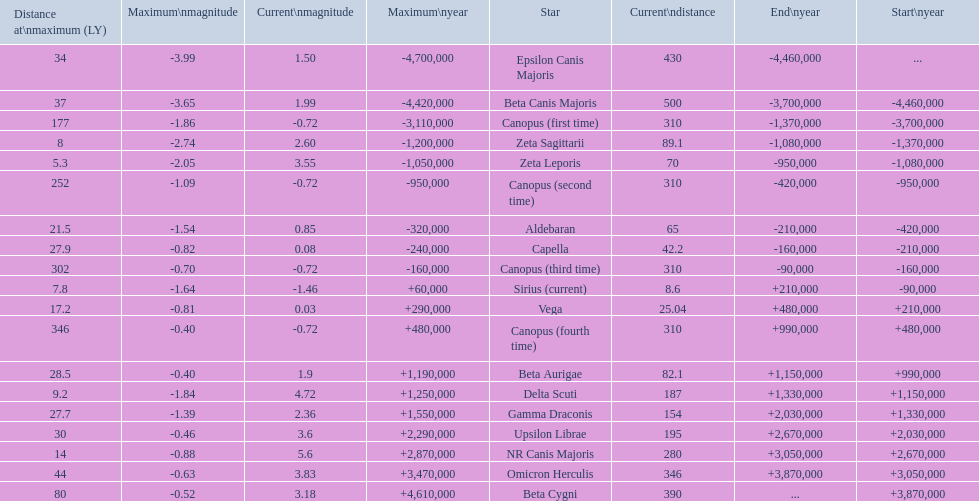Give me the full table as a dictionary. {'header': ['Distance at\\nmaximum (LY)', 'Maximum\\nmagnitude', 'Current\\nmagnitude', 'Maximum\\nyear', 'Star', 'Current\\ndistance', 'End\\nyear', 'Start\\nyear'], 'rows': [['34', '-3.99', '1.50', '-4,700,000', 'Epsilon Canis Majoris', '430', '-4,460,000', '...'], ['37', '-3.65', '1.99', '-4,420,000', 'Beta Canis Majoris', '500', '-3,700,000', '-4,460,000'], ['177', '-1.86', '-0.72', '-3,110,000', 'Canopus (first time)', '310', '-1,370,000', '-3,700,000'], ['8', '-2.74', '2.60', '-1,200,000', 'Zeta Sagittarii', '89.1', '-1,080,000', '-1,370,000'], ['5.3', '-2.05', '3.55', '-1,050,000', 'Zeta Leporis', '70', '-950,000', '-1,080,000'], ['252', '-1.09', '-0.72', '-950,000', 'Canopus (second time)', '310', '-420,000', '-950,000'], ['21.5', '-1.54', '0.85', '-320,000', 'Aldebaran', '65', '-210,000', '-420,000'], ['27.9', '-0.82', '0.08', '-240,000', 'Capella', '42.2', '-160,000', '-210,000'], ['302', '-0.70', '-0.72', '-160,000', 'Canopus (third time)', '310', '-90,000', '-160,000'], ['7.8', '-1.64', '-1.46', '+60,000', 'Sirius (current)', '8.6', '+210,000', '-90,000'], ['17.2', '-0.81', '0.03', '+290,000', 'Vega', '25.04', '+480,000', '+210,000'], ['346', '-0.40', '-0.72', '+480,000', 'Canopus (fourth time)', '310', '+990,000', '+480,000'], ['28.5', '-0.40', '1.9', '+1,190,000', 'Beta Aurigae', '82.1', '+1,150,000', '+990,000'], ['9.2', '-1.84', '4.72', '+1,250,000', 'Delta Scuti', '187', '+1,330,000', '+1,150,000'], ['27.7', '-1.39', '2.36', '+1,550,000', 'Gamma Draconis', '154', '+2,030,000', '+1,330,000'], ['30', '-0.46', '3.6', '+2,290,000', 'Upsilon Librae', '195', '+2,670,000', '+2,030,000'], ['14', '-0.88', '5.6', '+2,870,000', 'NR Canis Majoris', '280', '+3,050,000', '+2,670,000'], ['44', '-0.63', '3.83', '+3,470,000', 'Omicron Herculis', '346', '+3,870,000', '+3,050,000'], ['80', '-0.52', '3.18', '+4,610,000', 'Beta Cygni', '390', '...', '+3,870,000']]} How many stars have a distance at maximum of 30 light years or higher? 9. 